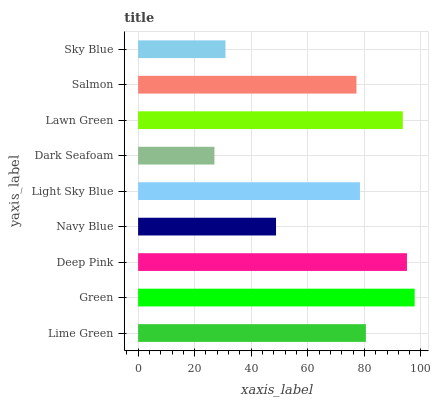Is Dark Seafoam the minimum?
Answer yes or no. Yes. Is Green the maximum?
Answer yes or no. Yes. Is Deep Pink the minimum?
Answer yes or no. No. Is Deep Pink the maximum?
Answer yes or no. No. Is Green greater than Deep Pink?
Answer yes or no. Yes. Is Deep Pink less than Green?
Answer yes or no. Yes. Is Deep Pink greater than Green?
Answer yes or no. No. Is Green less than Deep Pink?
Answer yes or no. No. Is Light Sky Blue the high median?
Answer yes or no. Yes. Is Light Sky Blue the low median?
Answer yes or no. Yes. Is Deep Pink the high median?
Answer yes or no. No. Is Lawn Green the low median?
Answer yes or no. No. 